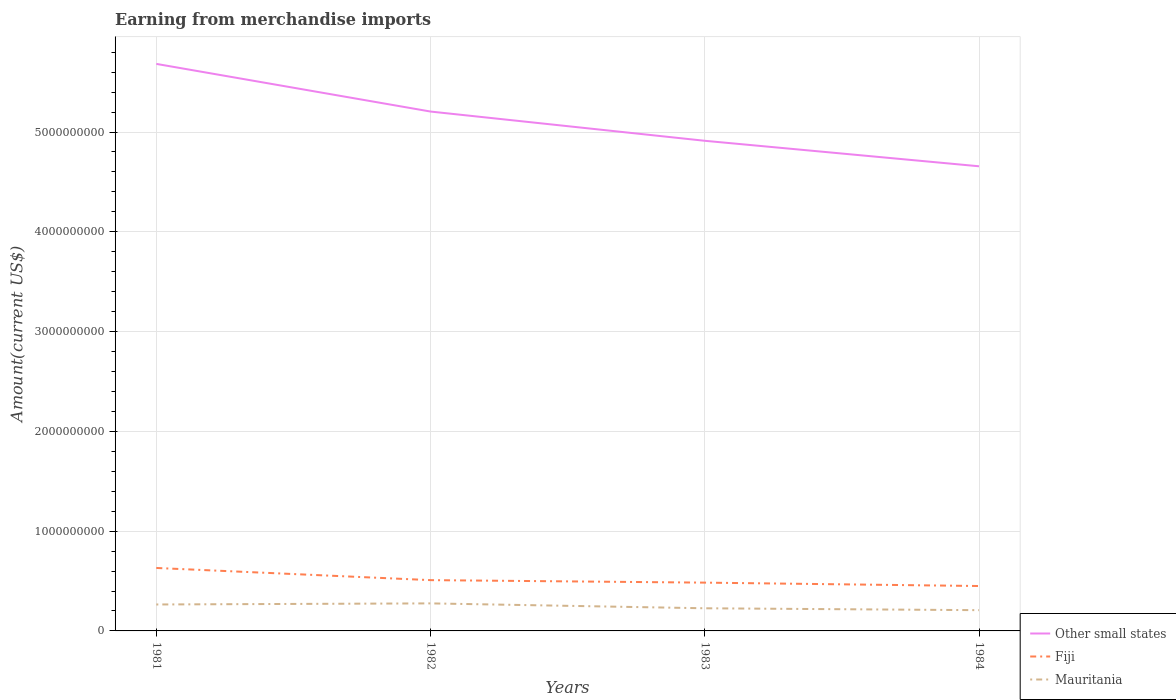How many different coloured lines are there?
Keep it short and to the point. 3. Across all years, what is the maximum amount earned from merchandise imports in Fiji?
Your response must be concise. 4.50e+08. What is the total amount earned from merchandise imports in Fiji in the graph?
Provide a short and direct response. 1.81e+08. What is the difference between the highest and the second highest amount earned from merchandise imports in Fiji?
Keep it short and to the point. 1.81e+08. What is the difference between the highest and the lowest amount earned from merchandise imports in Other small states?
Offer a very short reply. 2. Is the amount earned from merchandise imports in Mauritania strictly greater than the amount earned from merchandise imports in Other small states over the years?
Keep it short and to the point. Yes. What is the difference between two consecutive major ticks on the Y-axis?
Your response must be concise. 1.00e+09. Where does the legend appear in the graph?
Offer a terse response. Bottom right. How many legend labels are there?
Your answer should be compact. 3. What is the title of the graph?
Offer a very short reply. Earning from merchandise imports. What is the label or title of the Y-axis?
Offer a very short reply. Amount(current US$). What is the Amount(current US$) of Other small states in 1981?
Ensure brevity in your answer.  5.68e+09. What is the Amount(current US$) of Fiji in 1981?
Give a very brief answer. 6.31e+08. What is the Amount(current US$) of Mauritania in 1981?
Offer a very short reply. 2.65e+08. What is the Amount(current US$) of Other small states in 1982?
Your answer should be compact. 5.21e+09. What is the Amount(current US$) in Fiji in 1982?
Provide a short and direct response. 5.09e+08. What is the Amount(current US$) of Mauritania in 1982?
Ensure brevity in your answer.  2.76e+08. What is the Amount(current US$) of Other small states in 1983?
Your response must be concise. 4.91e+09. What is the Amount(current US$) of Fiji in 1983?
Offer a very short reply. 4.84e+08. What is the Amount(current US$) of Mauritania in 1983?
Keep it short and to the point. 2.27e+08. What is the Amount(current US$) of Other small states in 1984?
Provide a short and direct response. 4.66e+09. What is the Amount(current US$) of Fiji in 1984?
Offer a terse response. 4.50e+08. What is the Amount(current US$) in Mauritania in 1984?
Offer a terse response. 2.08e+08. Across all years, what is the maximum Amount(current US$) of Other small states?
Ensure brevity in your answer.  5.68e+09. Across all years, what is the maximum Amount(current US$) of Fiji?
Offer a terse response. 6.31e+08. Across all years, what is the maximum Amount(current US$) of Mauritania?
Provide a short and direct response. 2.76e+08. Across all years, what is the minimum Amount(current US$) in Other small states?
Offer a very short reply. 4.66e+09. Across all years, what is the minimum Amount(current US$) of Fiji?
Your answer should be very brief. 4.50e+08. Across all years, what is the minimum Amount(current US$) in Mauritania?
Your answer should be very brief. 2.08e+08. What is the total Amount(current US$) of Other small states in the graph?
Provide a succinct answer. 2.05e+1. What is the total Amount(current US$) in Fiji in the graph?
Offer a very short reply. 2.07e+09. What is the total Amount(current US$) in Mauritania in the graph?
Offer a terse response. 9.76e+08. What is the difference between the Amount(current US$) in Other small states in 1981 and that in 1982?
Give a very brief answer. 4.78e+08. What is the difference between the Amount(current US$) in Fiji in 1981 and that in 1982?
Keep it short and to the point. 1.22e+08. What is the difference between the Amount(current US$) of Mauritania in 1981 and that in 1982?
Keep it short and to the point. -1.10e+07. What is the difference between the Amount(current US$) of Other small states in 1981 and that in 1983?
Ensure brevity in your answer.  7.71e+08. What is the difference between the Amount(current US$) of Fiji in 1981 and that in 1983?
Your response must be concise. 1.47e+08. What is the difference between the Amount(current US$) of Mauritania in 1981 and that in 1983?
Provide a succinct answer. 3.80e+07. What is the difference between the Amount(current US$) of Other small states in 1981 and that in 1984?
Offer a terse response. 1.03e+09. What is the difference between the Amount(current US$) in Fiji in 1981 and that in 1984?
Ensure brevity in your answer.  1.81e+08. What is the difference between the Amount(current US$) of Mauritania in 1981 and that in 1984?
Provide a succinct answer. 5.70e+07. What is the difference between the Amount(current US$) of Other small states in 1982 and that in 1983?
Keep it short and to the point. 2.93e+08. What is the difference between the Amount(current US$) of Fiji in 1982 and that in 1983?
Provide a short and direct response. 2.50e+07. What is the difference between the Amount(current US$) of Mauritania in 1982 and that in 1983?
Give a very brief answer. 4.90e+07. What is the difference between the Amount(current US$) of Other small states in 1982 and that in 1984?
Your answer should be very brief. 5.49e+08. What is the difference between the Amount(current US$) of Fiji in 1982 and that in 1984?
Ensure brevity in your answer.  5.90e+07. What is the difference between the Amount(current US$) in Mauritania in 1982 and that in 1984?
Provide a short and direct response. 6.80e+07. What is the difference between the Amount(current US$) in Other small states in 1983 and that in 1984?
Your answer should be very brief. 2.55e+08. What is the difference between the Amount(current US$) of Fiji in 1983 and that in 1984?
Make the answer very short. 3.40e+07. What is the difference between the Amount(current US$) of Mauritania in 1983 and that in 1984?
Your answer should be compact. 1.90e+07. What is the difference between the Amount(current US$) in Other small states in 1981 and the Amount(current US$) in Fiji in 1982?
Provide a succinct answer. 5.17e+09. What is the difference between the Amount(current US$) in Other small states in 1981 and the Amount(current US$) in Mauritania in 1982?
Ensure brevity in your answer.  5.41e+09. What is the difference between the Amount(current US$) of Fiji in 1981 and the Amount(current US$) of Mauritania in 1982?
Provide a succinct answer. 3.55e+08. What is the difference between the Amount(current US$) of Other small states in 1981 and the Amount(current US$) of Fiji in 1983?
Offer a terse response. 5.20e+09. What is the difference between the Amount(current US$) in Other small states in 1981 and the Amount(current US$) in Mauritania in 1983?
Your answer should be compact. 5.46e+09. What is the difference between the Amount(current US$) in Fiji in 1981 and the Amount(current US$) in Mauritania in 1983?
Keep it short and to the point. 4.04e+08. What is the difference between the Amount(current US$) in Other small states in 1981 and the Amount(current US$) in Fiji in 1984?
Provide a short and direct response. 5.23e+09. What is the difference between the Amount(current US$) in Other small states in 1981 and the Amount(current US$) in Mauritania in 1984?
Keep it short and to the point. 5.47e+09. What is the difference between the Amount(current US$) of Fiji in 1981 and the Amount(current US$) of Mauritania in 1984?
Offer a very short reply. 4.23e+08. What is the difference between the Amount(current US$) in Other small states in 1982 and the Amount(current US$) in Fiji in 1983?
Provide a succinct answer. 4.72e+09. What is the difference between the Amount(current US$) of Other small states in 1982 and the Amount(current US$) of Mauritania in 1983?
Ensure brevity in your answer.  4.98e+09. What is the difference between the Amount(current US$) in Fiji in 1982 and the Amount(current US$) in Mauritania in 1983?
Your answer should be very brief. 2.82e+08. What is the difference between the Amount(current US$) in Other small states in 1982 and the Amount(current US$) in Fiji in 1984?
Your answer should be compact. 4.76e+09. What is the difference between the Amount(current US$) in Other small states in 1982 and the Amount(current US$) in Mauritania in 1984?
Provide a short and direct response. 5.00e+09. What is the difference between the Amount(current US$) in Fiji in 1982 and the Amount(current US$) in Mauritania in 1984?
Make the answer very short. 3.01e+08. What is the difference between the Amount(current US$) in Other small states in 1983 and the Amount(current US$) in Fiji in 1984?
Make the answer very short. 4.46e+09. What is the difference between the Amount(current US$) of Other small states in 1983 and the Amount(current US$) of Mauritania in 1984?
Provide a succinct answer. 4.70e+09. What is the difference between the Amount(current US$) of Fiji in 1983 and the Amount(current US$) of Mauritania in 1984?
Make the answer very short. 2.76e+08. What is the average Amount(current US$) of Other small states per year?
Keep it short and to the point. 5.11e+09. What is the average Amount(current US$) in Fiji per year?
Offer a terse response. 5.18e+08. What is the average Amount(current US$) of Mauritania per year?
Keep it short and to the point. 2.44e+08. In the year 1981, what is the difference between the Amount(current US$) of Other small states and Amount(current US$) of Fiji?
Offer a terse response. 5.05e+09. In the year 1981, what is the difference between the Amount(current US$) in Other small states and Amount(current US$) in Mauritania?
Your answer should be very brief. 5.42e+09. In the year 1981, what is the difference between the Amount(current US$) of Fiji and Amount(current US$) of Mauritania?
Give a very brief answer. 3.66e+08. In the year 1982, what is the difference between the Amount(current US$) in Other small states and Amount(current US$) in Fiji?
Ensure brevity in your answer.  4.70e+09. In the year 1982, what is the difference between the Amount(current US$) of Other small states and Amount(current US$) of Mauritania?
Make the answer very short. 4.93e+09. In the year 1982, what is the difference between the Amount(current US$) in Fiji and Amount(current US$) in Mauritania?
Your answer should be very brief. 2.33e+08. In the year 1983, what is the difference between the Amount(current US$) of Other small states and Amount(current US$) of Fiji?
Provide a short and direct response. 4.43e+09. In the year 1983, what is the difference between the Amount(current US$) of Other small states and Amount(current US$) of Mauritania?
Offer a very short reply. 4.69e+09. In the year 1983, what is the difference between the Amount(current US$) in Fiji and Amount(current US$) in Mauritania?
Your response must be concise. 2.57e+08. In the year 1984, what is the difference between the Amount(current US$) of Other small states and Amount(current US$) of Fiji?
Provide a succinct answer. 4.21e+09. In the year 1984, what is the difference between the Amount(current US$) in Other small states and Amount(current US$) in Mauritania?
Your answer should be very brief. 4.45e+09. In the year 1984, what is the difference between the Amount(current US$) of Fiji and Amount(current US$) of Mauritania?
Keep it short and to the point. 2.42e+08. What is the ratio of the Amount(current US$) of Other small states in 1981 to that in 1982?
Your answer should be compact. 1.09. What is the ratio of the Amount(current US$) in Fiji in 1981 to that in 1982?
Your response must be concise. 1.24. What is the ratio of the Amount(current US$) of Mauritania in 1981 to that in 1982?
Make the answer very short. 0.96. What is the ratio of the Amount(current US$) in Other small states in 1981 to that in 1983?
Provide a short and direct response. 1.16. What is the ratio of the Amount(current US$) in Fiji in 1981 to that in 1983?
Keep it short and to the point. 1.3. What is the ratio of the Amount(current US$) of Mauritania in 1981 to that in 1983?
Provide a short and direct response. 1.17. What is the ratio of the Amount(current US$) in Other small states in 1981 to that in 1984?
Your answer should be compact. 1.22. What is the ratio of the Amount(current US$) in Fiji in 1981 to that in 1984?
Provide a short and direct response. 1.4. What is the ratio of the Amount(current US$) of Mauritania in 1981 to that in 1984?
Provide a short and direct response. 1.27. What is the ratio of the Amount(current US$) of Other small states in 1982 to that in 1983?
Offer a terse response. 1.06. What is the ratio of the Amount(current US$) in Fiji in 1982 to that in 1983?
Keep it short and to the point. 1.05. What is the ratio of the Amount(current US$) in Mauritania in 1982 to that in 1983?
Make the answer very short. 1.22. What is the ratio of the Amount(current US$) in Other small states in 1982 to that in 1984?
Offer a terse response. 1.12. What is the ratio of the Amount(current US$) of Fiji in 1982 to that in 1984?
Offer a terse response. 1.13. What is the ratio of the Amount(current US$) of Mauritania in 1982 to that in 1984?
Ensure brevity in your answer.  1.33. What is the ratio of the Amount(current US$) in Other small states in 1983 to that in 1984?
Your response must be concise. 1.05. What is the ratio of the Amount(current US$) in Fiji in 1983 to that in 1984?
Offer a very short reply. 1.08. What is the ratio of the Amount(current US$) of Mauritania in 1983 to that in 1984?
Keep it short and to the point. 1.09. What is the difference between the highest and the second highest Amount(current US$) of Other small states?
Offer a terse response. 4.78e+08. What is the difference between the highest and the second highest Amount(current US$) in Fiji?
Give a very brief answer. 1.22e+08. What is the difference between the highest and the second highest Amount(current US$) in Mauritania?
Give a very brief answer. 1.10e+07. What is the difference between the highest and the lowest Amount(current US$) in Other small states?
Provide a succinct answer. 1.03e+09. What is the difference between the highest and the lowest Amount(current US$) in Fiji?
Make the answer very short. 1.81e+08. What is the difference between the highest and the lowest Amount(current US$) of Mauritania?
Keep it short and to the point. 6.80e+07. 